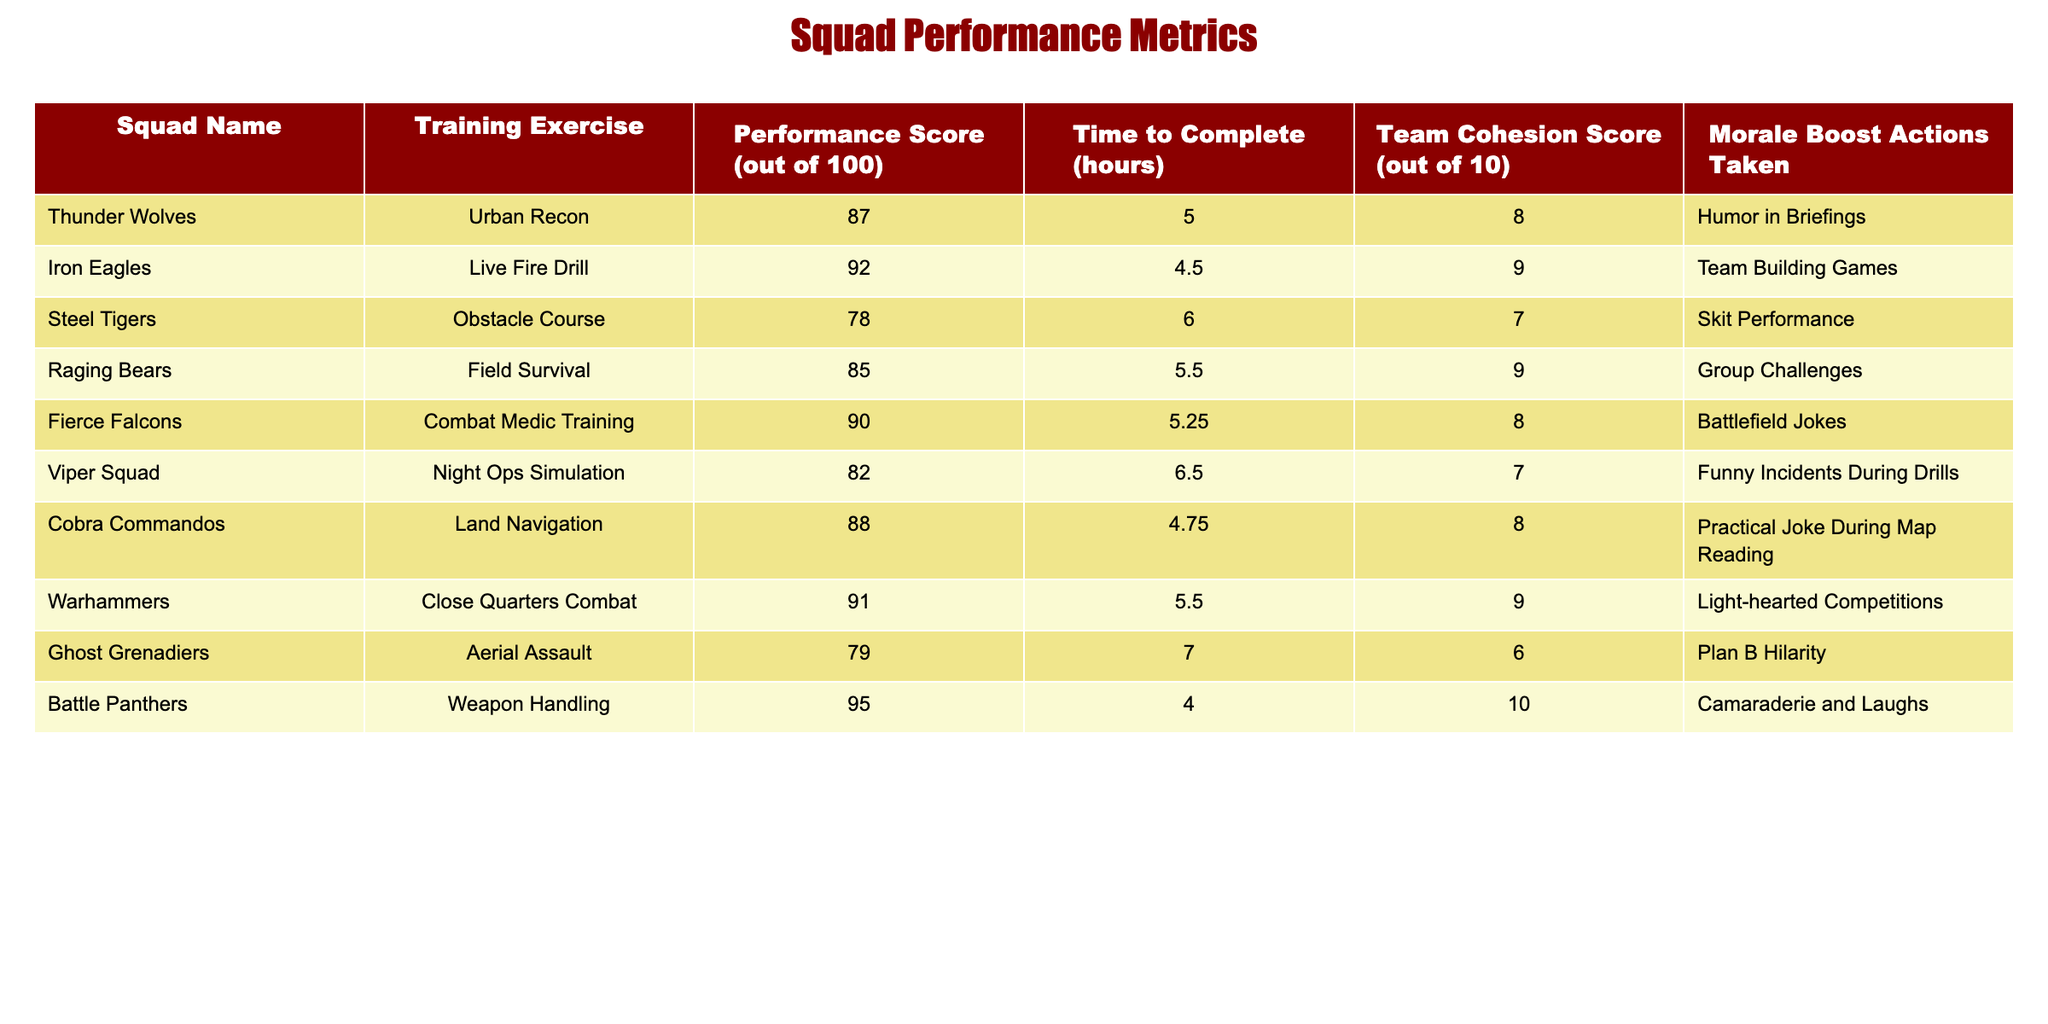What's the highest performance score achieved by a squad? Looking at the 'Performance Score' column, the highest score is 95, achieved by the Battle Panthers.
Answer: 95 Which squad had the longest time to complete their training exercise? By examining the 'Time to Complete' column, the longest time recorded is 7 hours, which corresponds to the Ghost Grenadiers.
Answer: 7 hours What is the average Team Cohesion Score for all squads? Adding up all Team Cohesion Scores (8 + 9 + 7 + 9 + 8 + 7 + 8 + 9 + 6 + 10 = 81) and dividing by the number of squads (10) gives an average of 81 / 10 = 8.1.
Answer: 8.1 Did any squad take less than 5 hours to complete their training exercise? Looking through the 'Time to Complete' column, only the Battle Panthers (4 hours) and Iron Eagles (4.5 hours) completed their exercises in less than 5 hours.
Answer: Yes Which training exercise had the highest morale boost actions taken? The 'Morale Boost Actions Taken' column shows that the actions labeled as 'Camaraderie and Laughs' by the Battle Panthers correlates with the highest Team Cohesion Score of 10.
Answer: Camaraderie and Laughs What is the performance score difference between the Thunder Wolves and the Steel Tigers? The Thunder Wolves scored 87 while the Steel Tigers scored 78. Therefore, the difference is 87 - 78 = 9.
Answer: 9 Which squad demonstrated the best time-to-complete performance relative to their performance score? Iron Eagles completed the Live Fire Drill in 4.5 hours with a score of 92, which is a high performance for a short time. Evaluating others, they have the best ratio of performance score to time.
Answer: Iron Eagles Is there a squad that scored above 90 and also had a Team Cohesion Score of 10? Checking the performance score and Team Cohesion Score, the only squad that scored above 90 is Battle Panthers, which did achieve a Team Cohesion Score of 10.
Answer: No What is the total time to complete all exercises across all squads? Adding the 'Time to Complete' values (5 + 4.5 + 6 + 5.5 + 5.25 + 6.5 + 4.75 + 5.5 + 7 + 4 = 56.5) gives a total of 56.5 hours.
Answer: 56.5 hours 